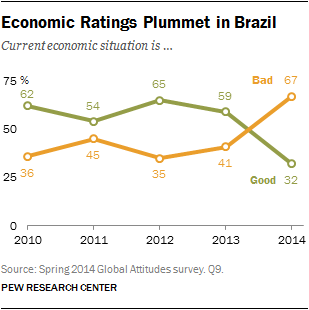Draw attention to some important aspects in this diagram. The bad and good graph crossed each other after 2013, with the answer being yes. The ratio of the smallest orange and green data points is 1.09375... 